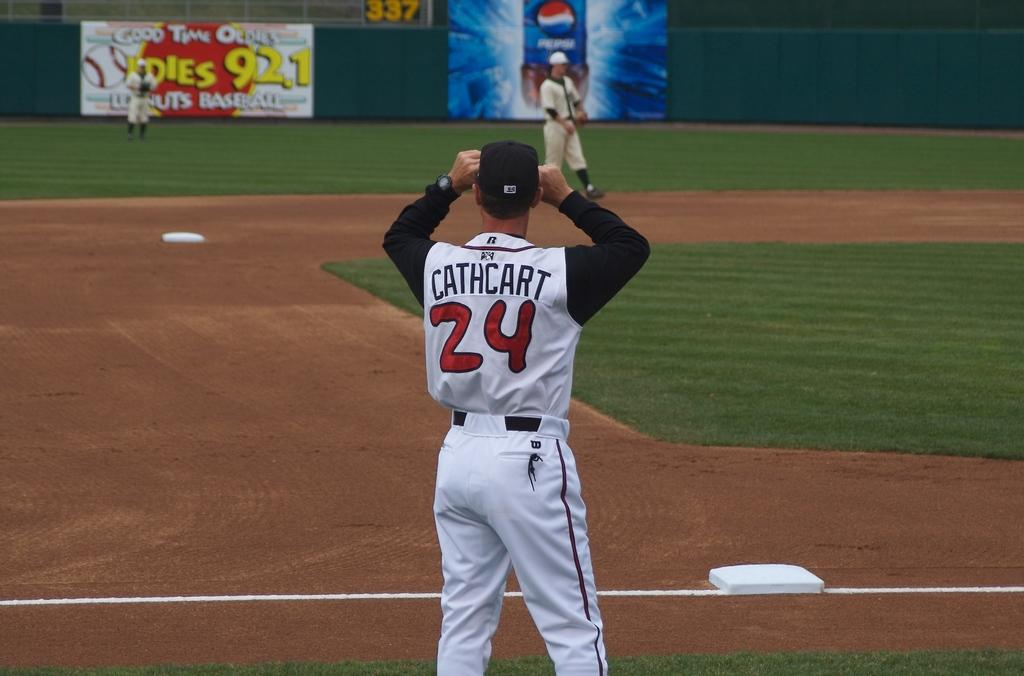<image>
Present a compact description of the photo's key features. A baseball player named Cathcart wears the number 24. 